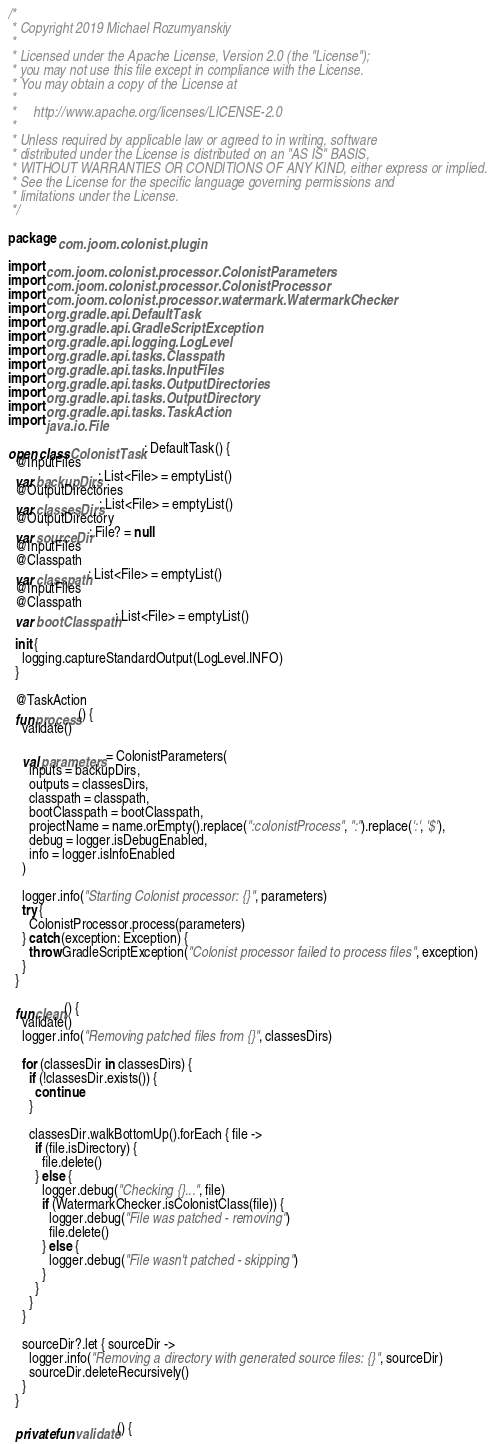<code> <loc_0><loc_0><loc_500><loc_500><_Kotlin_>/*
 * Copyright 2019 Michael Rozumyanskiy
 *
 * Licensed under the Apache License, Version 2.0 (the "License");
 * you may not use this file except in compliance with the License.
 * You may obtain a copy of the License at
 *
 *     http://www.apache.org/licenses/LICENSE-2.0
 *
 * Unless required by applicable law or agreed to in writing, software
 * distributed under the License is distributed on an "AS IS" BASIS,
 * WITHOUT WARRANTIES OR CONDITIONS OF ANY KIND, either express or implied.
 * See the License for the specific language governing permissions and
 * limitations under the License.
 */

package com.joom.colonist.plugin

import com.joom.colonist.processor.ColonistParameters
import com.joom.colonist.processor.ColonistProcessor
import com.joom.colonist.processor.watermark.WatermarkChecker
import org.gradle.api.DefaultTask
import org.gradle.api.GradleScriptException
import org.gradle.api.logging.LogLevel
import org.gradle.api.tasks.Classpath
import org.gradle.api.tasks.InputFiles
import org.gradle.api.tasks.OutputDirectories
import org.gradle.api.tasks.OutputDirectory
import org.gradle.api.tasks.TaskAction
import java.io.File

open class ColonistTask : DefaultTask() {
  @InputFiles
  var backupDirs: List<File> = emptyList()
  @OutputDirectories
  var classesDirs: List<File> = emptyList()
  @OutputDirectory
  var sourceDir: File? = null
  @InputFiles
  @Classpath
  var classpath: List<File> = emptyList()
  @InputFiles
  @Classpath
  var bootClasspath: List<File> = emptyList()

  init {
    logging.captureStandardOutput(LogLevel.INFO)
  }

  @TaskAction
  fun process() {
    validate()

    val parameters = ColonistParameters(
      inputs = backupDirs,
      outputs = classesDirs,
      classpath = classpath,
      bootClasspath = bootClasspath,
      projectName = name.orEmpty().replace(":colonistProcess", ":").replace(':', '$'),
      debug = logger.isDebugEnabled,
      info = logger.isInfoEnabled
    )

    logger.info("Starting Colonist processor: {}", parameters)
    try {
      ColonistProcessor.process(parameters)
    } catch (exception: Exception) {
      throw GradleScriptException("Colonist processor failed to process files", exception)
    }
  }

  fun clean() {
    validate()
    logger.info("Removing patched files from {}", classesDirs)

    for (classesDir in classesDirs) {
      if (!classesDir.exists()) {
        continue
      }

      classesDir.walkBottomUp().forEach { file ->
        if (file.isDirectory) {
          file.delete()
        } else {
          logger.debug("Checking {}...", file)
          if (WatermarkChecker.isColonistClass(file)) {
            logger.debug("File was patched - removing")
            file.delete()
          } else {
            logger.debug("File wasn't patched - skipping")
          }
        }
      }
    }

    sourceDir?.let { sourceDir ->
      logger.info("Removing a directory with generated source files: {}", sourceDir)
      sourceDir.deleteRecursively()
    }
  }

  private fun validate() {</code> 